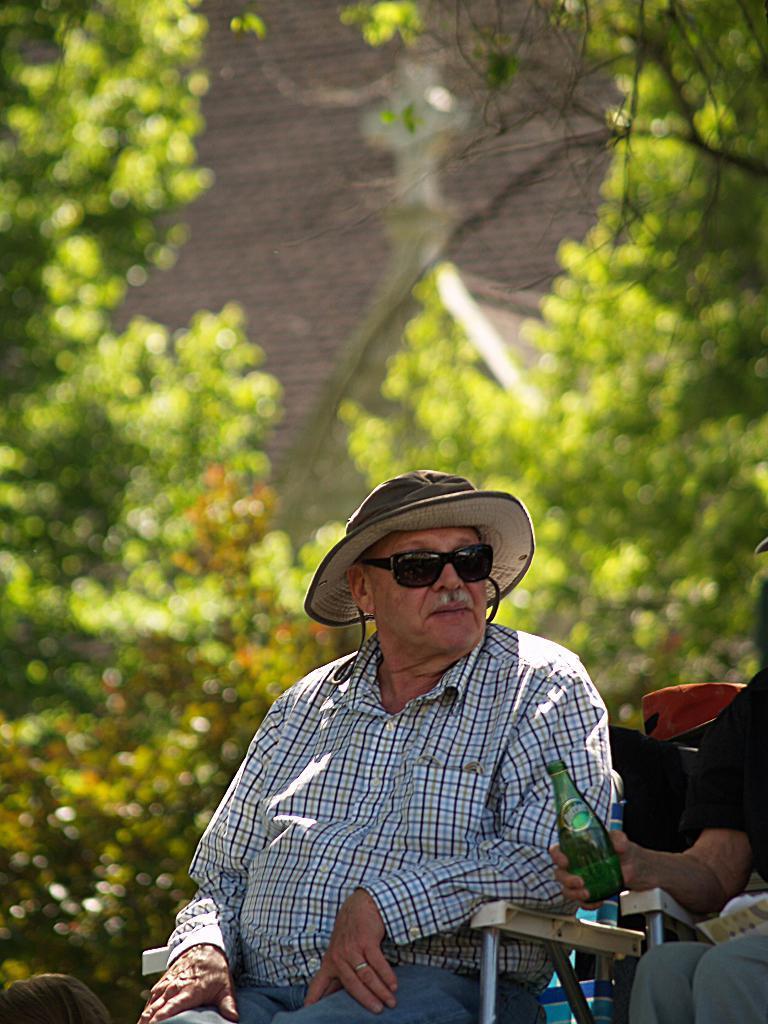How would you summarize this image in a sentence or two? In the image I can see there is a man sitting on the chair beside him there is another man sitting and holding bottle at the back there are so many trees. 